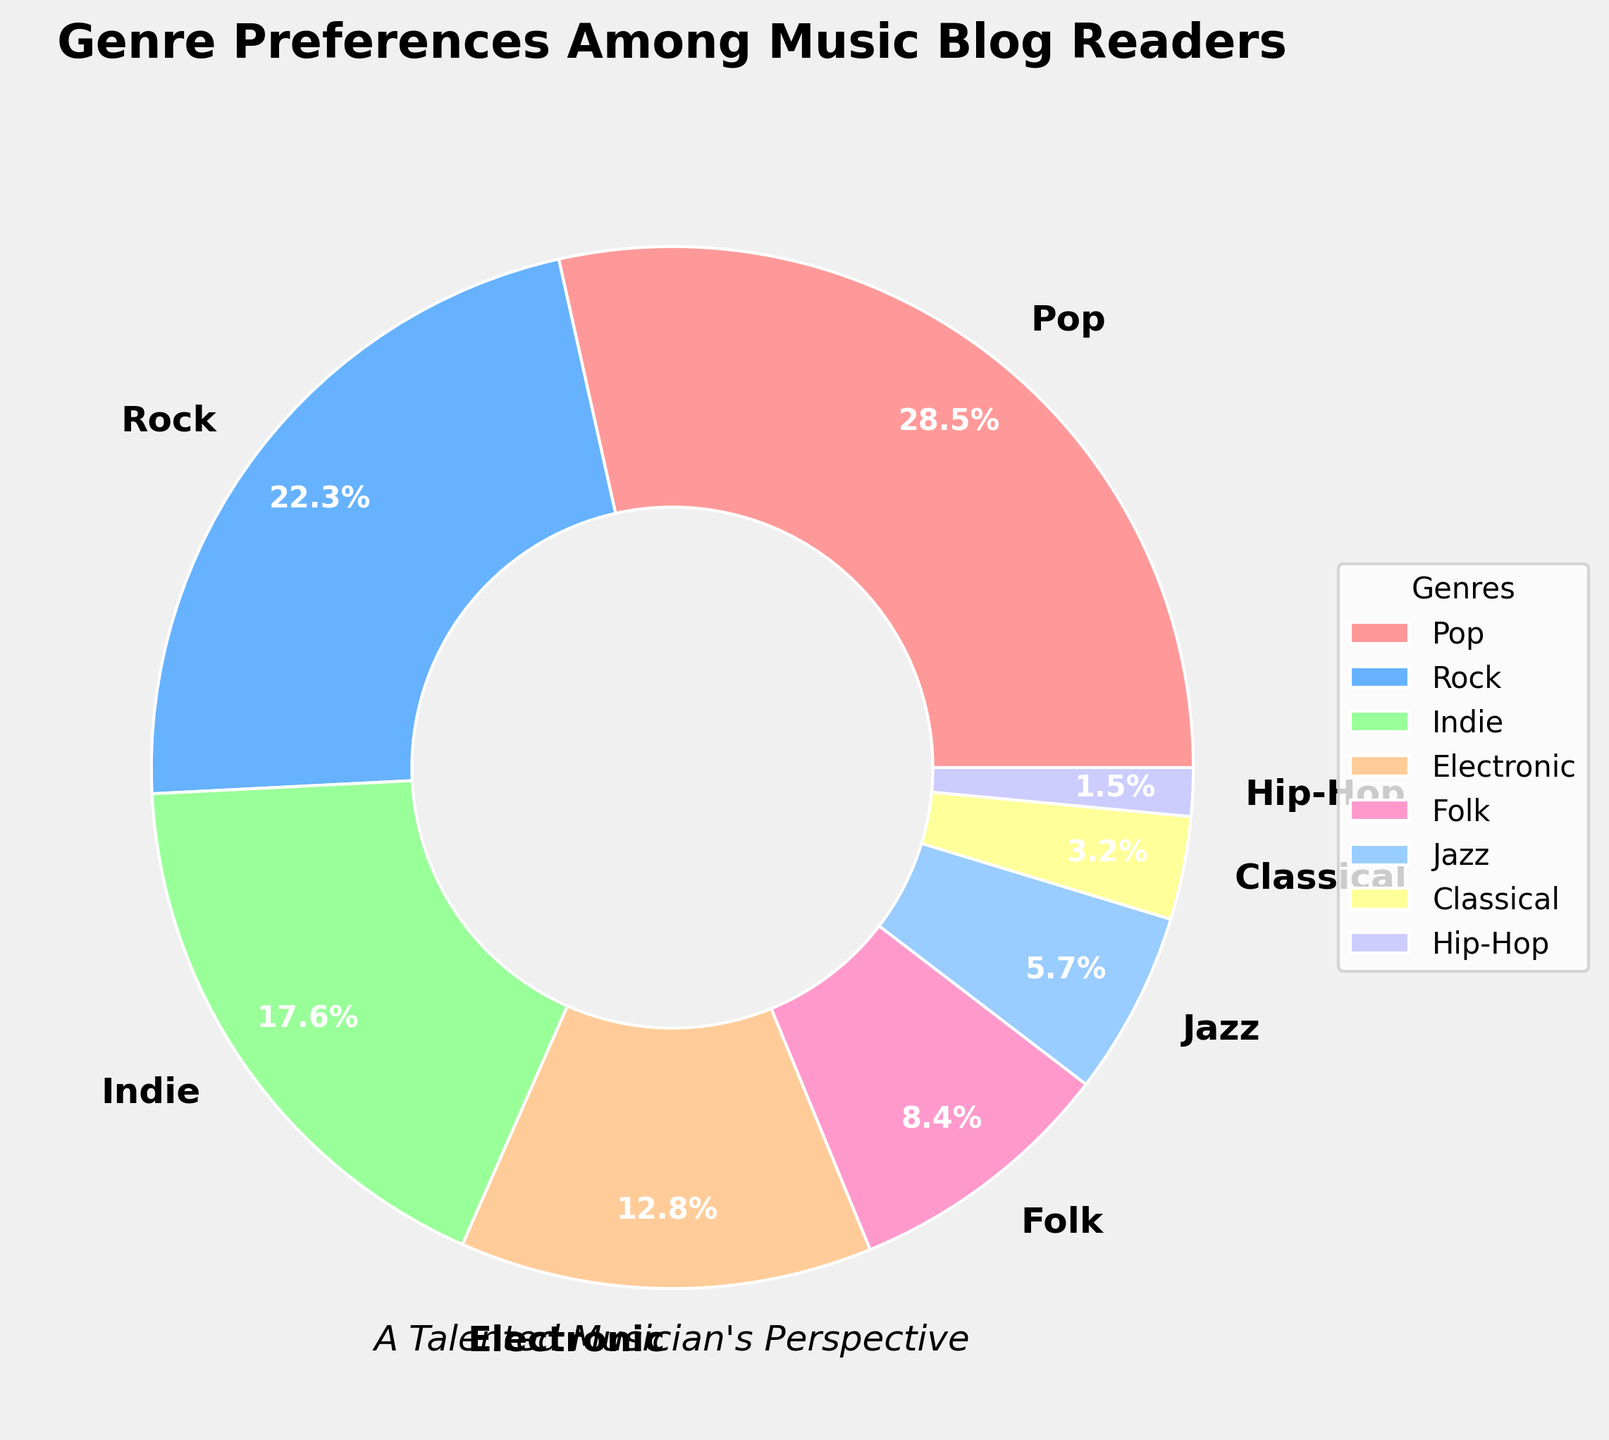What percentage of readers prefer Pop music? The pie chart has labels showing percentages for different genres. The label for Pop music shows 28.5%.
Answer: 28.5% Which genre has the smallest percentage of preferences? Looking at the pie chart, the genre with the smallest percentage is Hip-Hop, labeled at 1.5%.
Answer: Hip-Hop How much more popular is Rock music compared to Jazz music among the readers? Rock music is preferred by 22.3% of readers, whereas Jazz is preferred by 5.7%. The difference is 22.3% - 5.7% = 16.6%.
Answer: 16.6% What is the cumulative percentage of readers who prefer Indie and Folk music? Indie music is preferred by 17.6% of readers and Folk by 8.4%. The sum is 17.6% + 8.4% = 26.0%.
Answer: 26.0% What is the total percentage of readers who prefer either Electronic, Folk, or Classical music? Electronic music has 12.8%, Folk has 8.4%, and Classical has 3.2%. The sum is 12.8% + 8.4% + 3.2% = 24.4%.
Answer: 24.4% Which genre is more preferred: Electronic or Folk? By looking at the chart, Electronic is preferred by 12.8% while Folk is preferred by 8.4%. Electronic has a higher percentage.
Answer: Electronic What color is used to represent the Jazz genre? Observing the chart, Jazz is labeled with a light blue color.
Answer: Light Blue Which two genres combined make up more than 50% of the preferences? Pop has 28.5% and Rock has 22.3%. Combined, they make up 28.5% + 22.3% = 50.8%.
Answer: Pop and Rock 